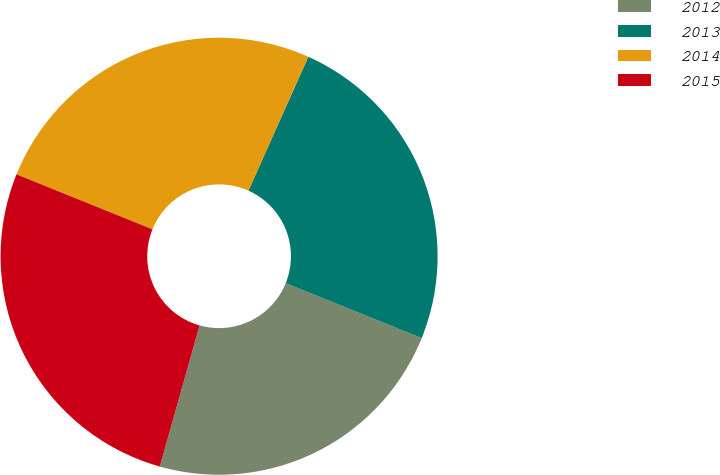Convert chart to OTSL. <chart><loc_0><loc_0><loc_500><loc_500><pie_chart><fcel>2012<fcel>2013<fcel>2014<fcel>2015<nl><fcel>23.26%<fcel>24.42%<fcel>25.58%<fcel>26.74%<nl></chart> 